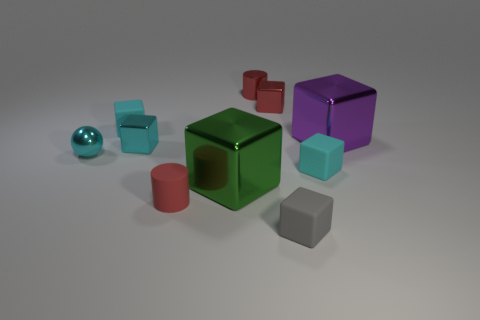How many small objects are green shiny blocks or red metallic cubes?
Make the answer very short. 1. What is the color of the small rubber cube that is to the left of the cylinder right of the red thing that is in front of the big purple block?
Provide a succinct answer. Cyan. How many other things are there of the same color as the shiny cylinder?
Make the answer very short. 2. What number of shiny objects are either cubes or small blue spheres?
Your answer should be compact. 4. Does the small cylinder behind the cyan sphere have the same color as the cylinder that is in front of the big purple cube?
Offer a terse response. Yes. Are there any other things that are the same material as the gray thing?
Make the answer very short. Yes. What is the size of the purple metallic object that is the same shape as the small gray thing?
Your answer should be very brief. Large. Is the number of tiny cyan shiny spheres that are behind the purple metallic object greater than the number of small cylinders?
Offer a terse response. No. Is the small gray thing that is to the left of the big purple metallic block made of the same material as the tiny ball?
Ensure brevity in your answer.  No. There is a cyan rubber object on the right side of the tiny cyan matte object that is left of the small thing that is on the right side of the tiny gray block; what is its size?
Your response must be concise. Small. 